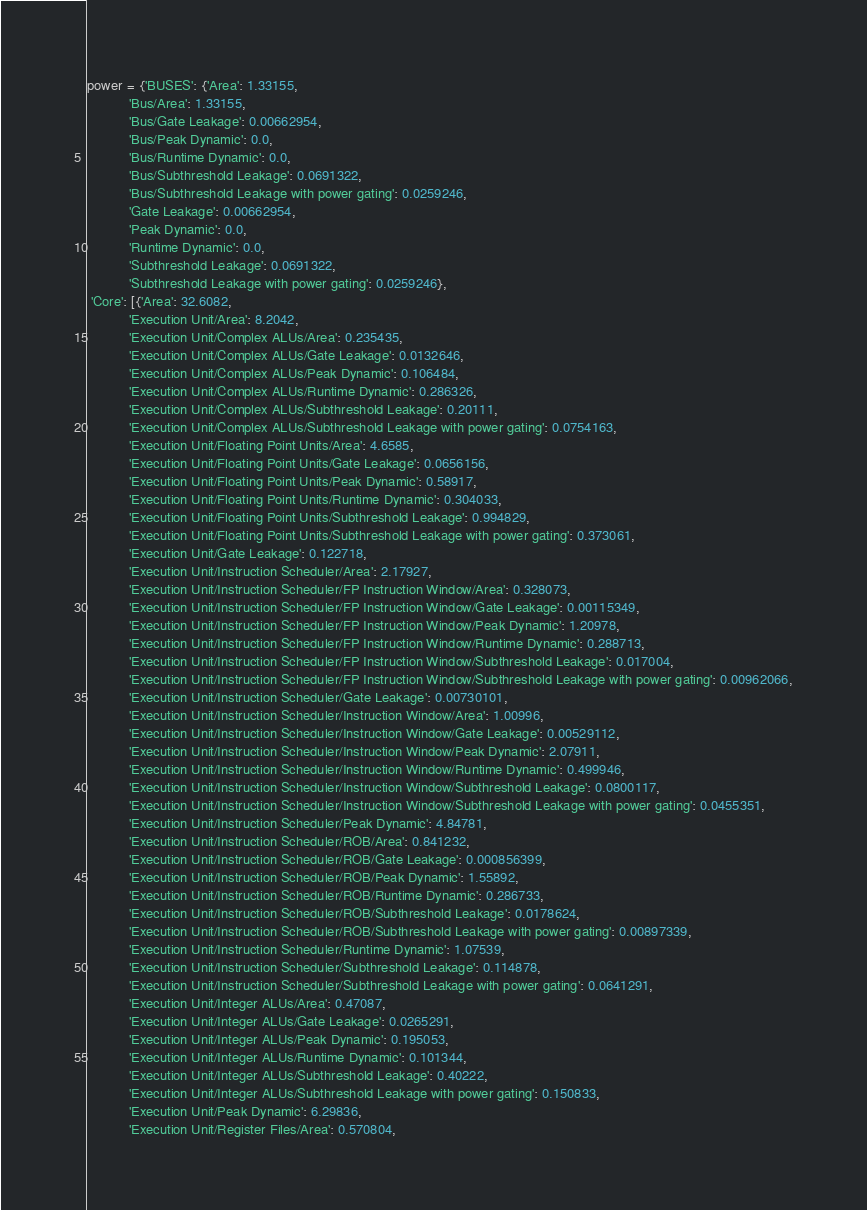<code> <loc_0><loc_0><loc_500><loc_500><_Python_>power = {'BUSES': {'Area': 1.33155,
           'Bus/Area': 1.33155,
           'Bus/Gate Leakage': 0.00662954,
           'Bus/Peak Dynamic': 0.0,
           'Bus/Runtime Dynamic': 0.0,
           'Bus/Subthreshold Leakage': 0.0691322,
           'Bus/Subthreshold Leakage with power gating': 0.0259246,
           'Gate Leakage': 0.00662954,
           'Peak Dynamic': 0.0,
           'Runtime Dynamic': 0.0,
           'Subthreshold Leakage': 0.0691322,
           'Subthreshold Leakage with power gating': 0.0259246},
 'Core': [{'Area': 32.6082,
           'Execution Unit/Area': 8.2042,
           'Execution Unit/Complex ALUs/Area': 0.235435,
           'Execution Unit/Complex ALUs/Gate Leakage': 0.0132646,
           'Execution Unit/Complex ALUs/Peak Dynamic': 0.106484,
           'Execution Unit/Complex ALUs/Runtime Dynamic': 0.286326,
           'Execution Unit/Complex ALUs/Subthreshold Leakage': 0.20111,
           'Execution Unit/Complex ALUs/Subthreshold Leakage with power gating': 0.0754163,
           'Execution Unit/Floating Point Units/Area': 4.6585,
           'Execution Unit/Floating Point Units/Gate Leakage': 0.0656156,
           'Execution Unit/Floating Point Units/Peak Dynamic': 0.58917,
           'Execution Unit/Floating Point Units/Runtime Dynamic': 0.304033,
           'Execution Unit/Floating Point Units/Subthreshold Leakage': 0.994829,
           'Execution Unit/Floating Point Units/Subthreshold Leakage with power gating': 0.373061,
           'Execution Unit/Gate Leakage': 0.122718,
           'Execution Unit/Instruction Scheduler/Area': 2.17927,
           'Execution Unit/Instruction Scheduler/FP Instruction Window/Area': 0.328073,
           'Execution Unit/Instruction Scheduler/FP Instruction Window/Gate Leakage': 0.00115349,
           'Execution Unit/Instruction Scheduler/FP Instruction Window/Peak Dynamic': 1.20978,
           'Execution Unit/Instruction Scheduler/FP Instruction Window/Runtime Dynamic': 0.288713,
           'Execution Unit/Instruction Scheduler/FP Instruction Window/Subthreshold Leakage': 0.017004,
           'Execution Unit/Instruction Scheduler/FP Instruction Window/Subthreshold Leakage with power gating': 0.00962066,
           'Execution Unit/Instruction Scheduler/Gate Leakage': 0.00730101,
           'Execution Unit/Instruction Scheduler/Instruction Window/Area': 1.00996,
           'Execution Unit/Instruction Scheduler/Instruction Window/Gate Leakage': 0.00529112,
           'Execution Unit/Instruction Scheduler/Instruction Window/Peak Dynamic': 2.07911,
           'Execution Unit/Instruction Scheduler/Instruction Window/Runtime Dynamic': 0.499946,
           'Execution Unit/Instruction Scheduler/Instruction Window/Subthreshold Leakage': 0.0800117,
           'Execution Unit/Instruction Scheduler/Instruction Window/Subthreshold Leakage with power gating': 0.0455351,
           'Execution Unit/Instruction Scheduler/Peak Dynamic': 4.84781,
           'Execution Unit/Instruction Scheduler/ROB/Area': 0.841232,
           'Execution Unit/Instruction Scheduler/ROB/Gate Leakage': 0.000856399,
           'Execution Unit/Instruction Scheduler/ROB/Peak Dynamic': 1.55892,
           'Execution Unit/Instruction Scheduler/ROB/Runtime Dynamic': 0.286733,
           'Execution Unit/Instruction Scheduler/ROB/Subthreshold Leakage': 0.0178624,
           'Execution Unit/Instruction Scheduler/ROB/Subthreshold Leakage with power gating': 0.00897339,
           'Execution Unit/Instruction Scheduler/Runtime Dynamic': 1.07539,
           'Execution Unit/Instruction Scheduler/Subthreshold Leakage': 0.114878,
           'Execution Unit/Instruction Scheduler/Subthreshold Leakage with power gating': 0.0641291,
           'Execution Unit/Integer ALUs/Area': 0.47087,
           'Execution Unit/Integer ALUs/Gate Leakage': 0.0265291,
           'Execution Unit/Integer ALUs/Peak Dynamic': 0.195053,
           'Execution Unit/Integer ALUs/Runtime Dynamic': 0.101344,
           'Execution Unit/Integer ALUs/Subthreshold Leakage': 0.40222,
           'Execution Unit/Integer ALUs/Subthreshold Leakage with power gating': 0.150833,
           'Execution Unit/Peak Dynamic': 6.29836,
           'Execution Unit/Register Files/Area': 0.570804,</code> 